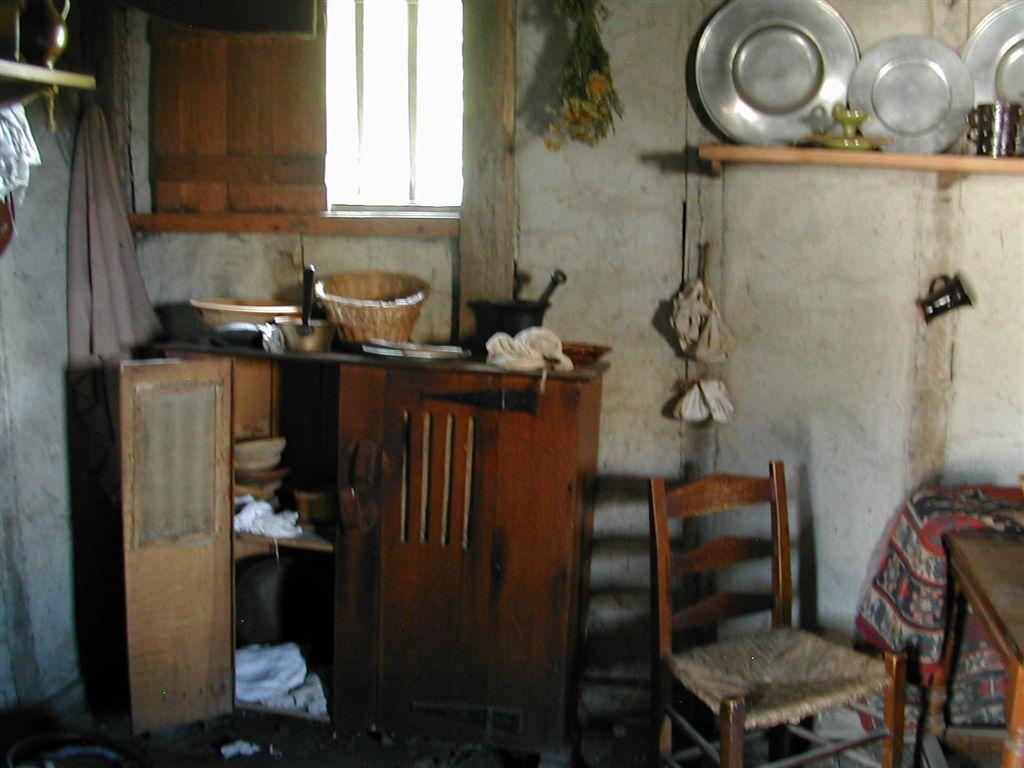In one or two sentences, can you explain what this image depicts? In the picture I can see the wooden cabinet on the floor and it is on the left side. I can see a plastic bowl, wooden basket and pans are kept on the wooden cabinet. I can see the wooden window on the top left side. I can see a wooden table and chair on the floor. I can see the stainless steel plates on the wooden support stand which is on the wall on the top right side of the picture. 